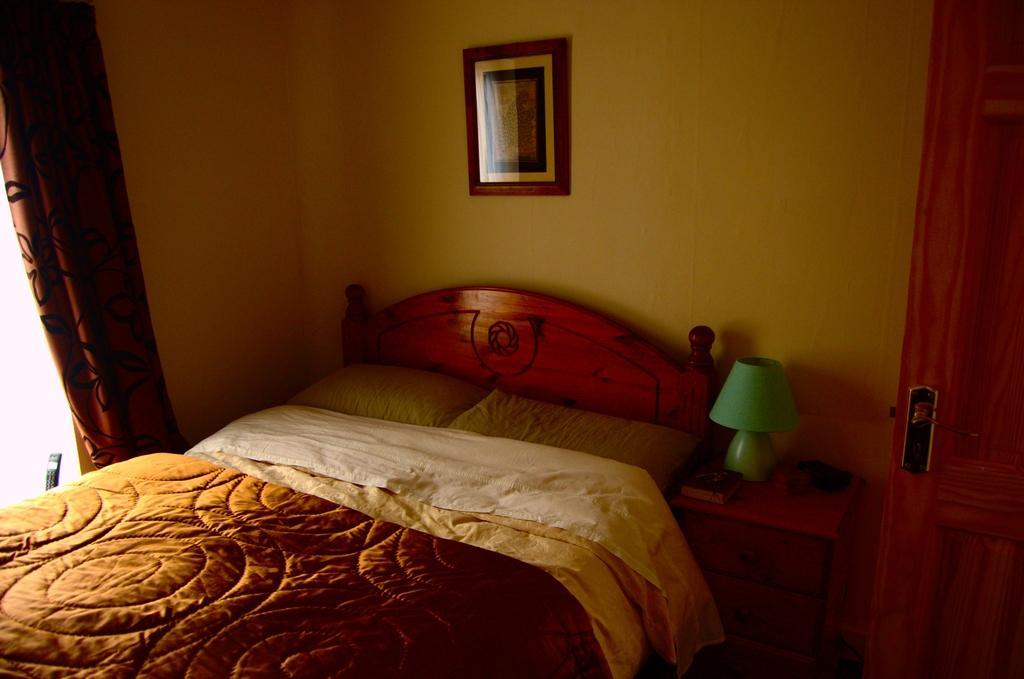Could you give a brief overview of what you see in this image? The image is taken in the room. In the center of the image there is a bed and cushions placed on the bed, next to the bed there is a stand and lamp placed on the stand. In the background there is a door, curtains,and a wall. 